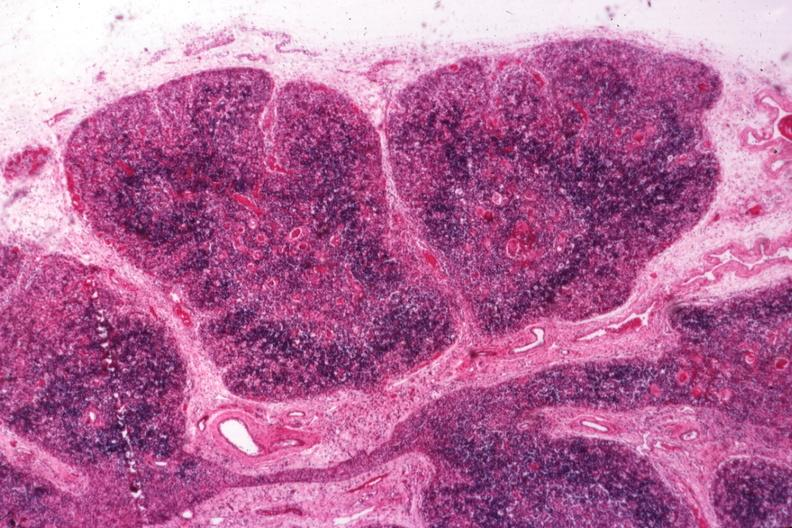what is present?
Answer the question using a single word or phrase. Hematologic 